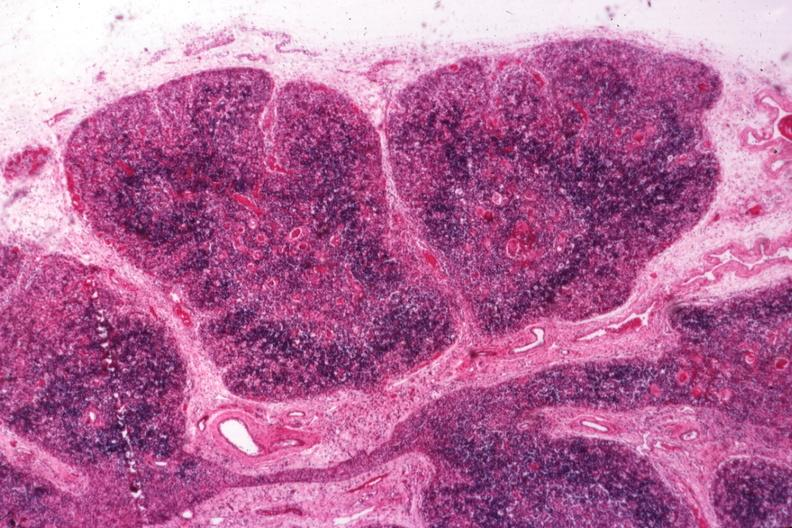what is present?
Answer the question using a single word or phrase. Hematologic 